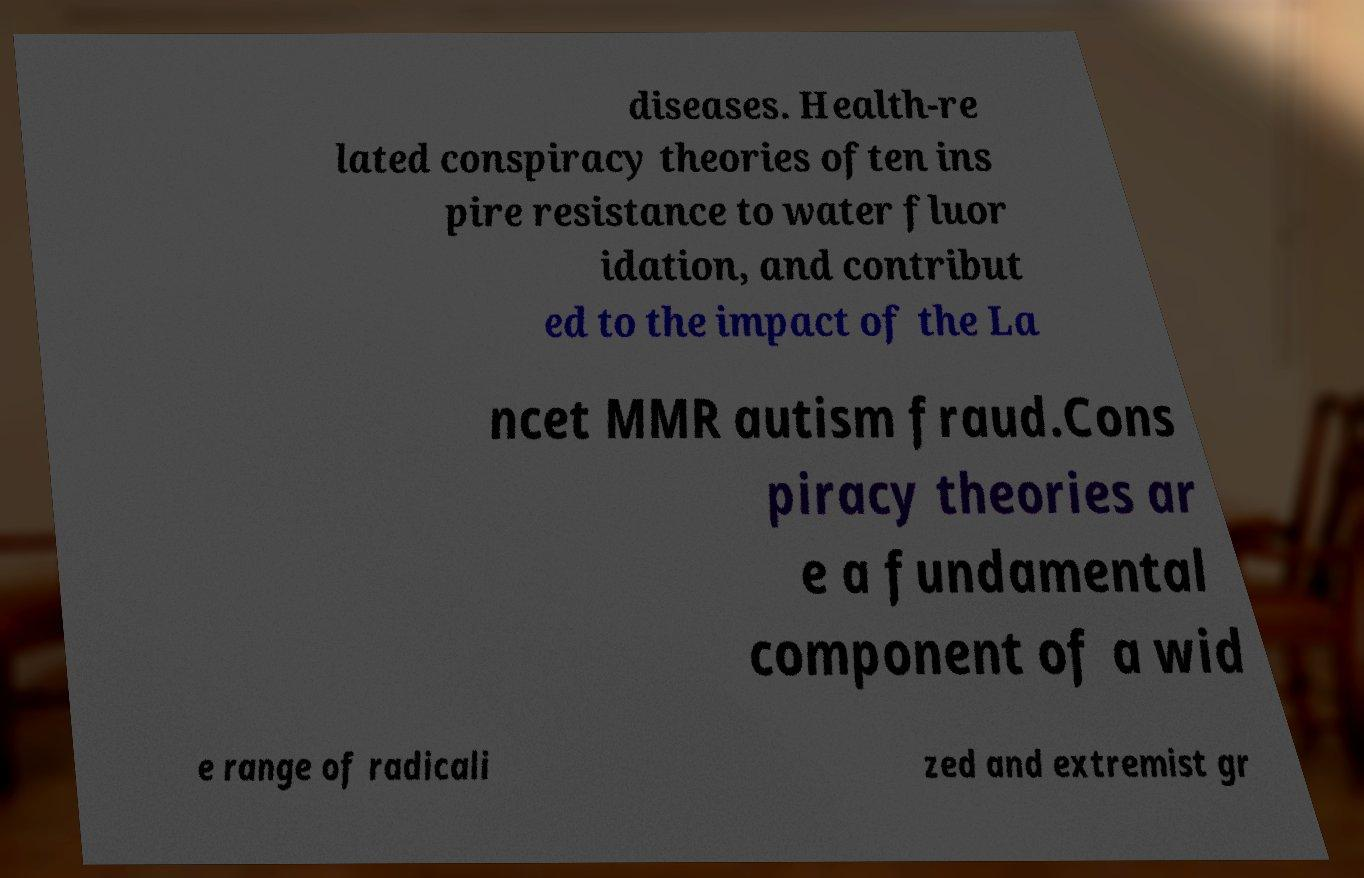Can you read and provide the text displayed in the image?This photo seems to have some interesting text. Can you extract and type it out for me? diseases. Health-re lated conspiracy theories often ins pire resistance to water fluor idation, and contribut ed to the impact of the La ncet MMR autism fraud.Cons piracy theories ar e a fundamental component of a wid e range of radicali zed and extremist gr 